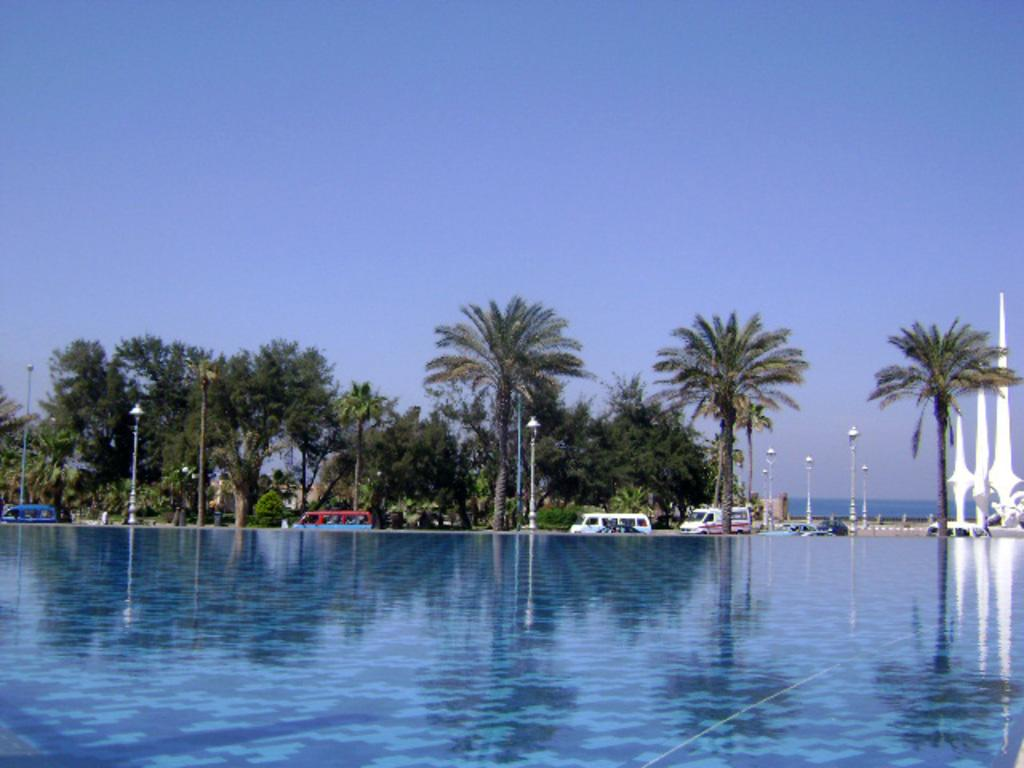What type of setting is depicted in the image? The image is an outside view. What natural elements can be seen in the image? There are trees in the image. What man-made objects are present in the image? There are vehicles in the image. What is visible in the background of the image? The sky is visible in the background of the image. What type of territory does the writer own in the image? There is no writer or territory present in the image. 